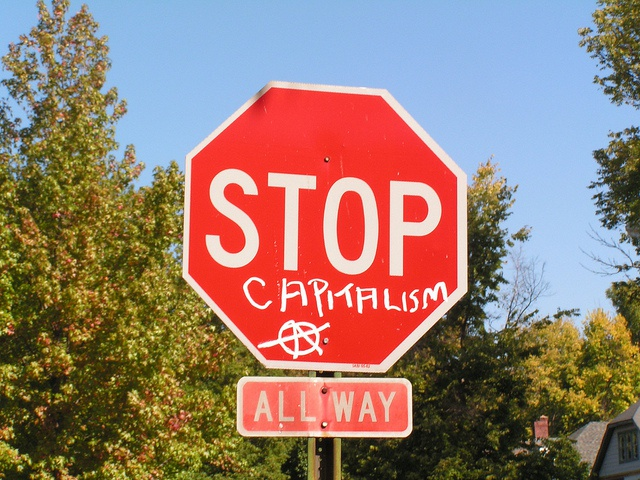Describe the objects in this image and their specific colors. I can see a stop sign in lightblue, red, lightgray, salmon, and lightpink tones in this image. 